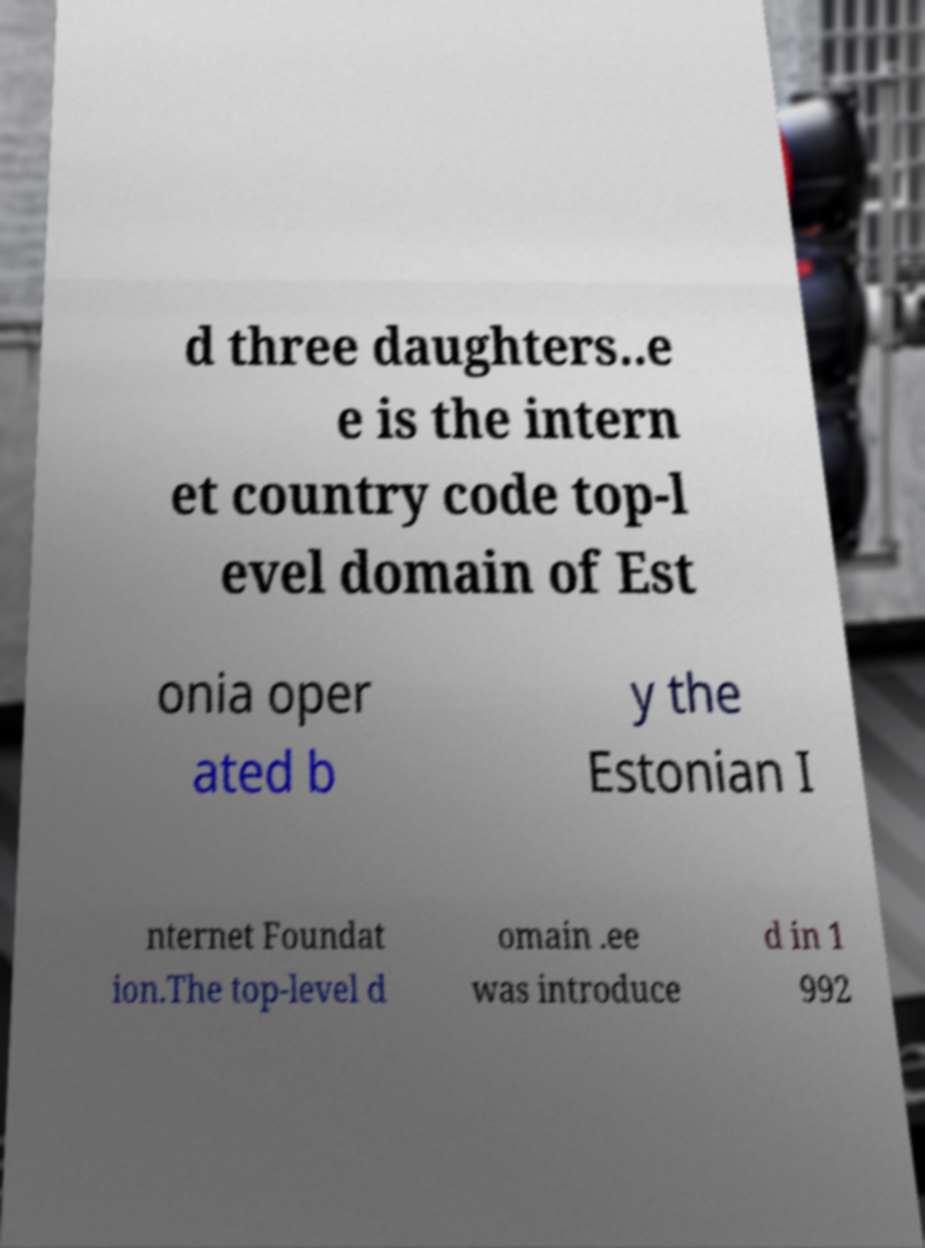Could you assist in decoding the text presented in this image and type it out clearly? d three daughters..e e is the intern et country code top-l evel domain of Est onia oper ated b y the Estonian I nternet Foundat ion.The top-level d omain .ee was introduce d in 1 992 